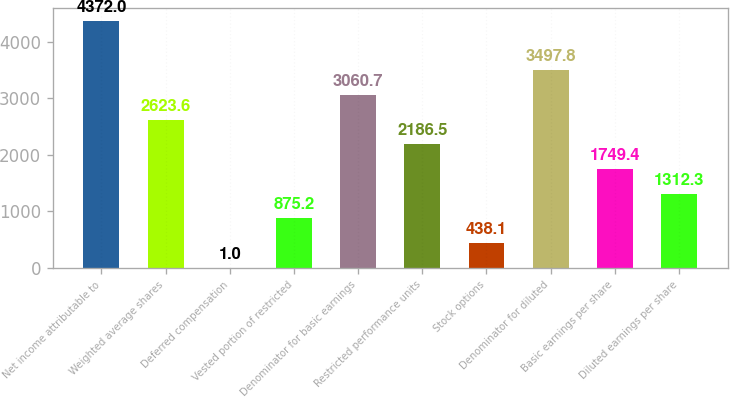Convert chart to OTSL. <chart><loc_0><loc_0><loc_500><loc_500><bar_chart><fcel>Net income attributable to<fcel>Weighted average shares<fcel>Deferred compensation<fcel>Vested portion of restricted<fcel>Denominator for basic earnings<fcel>Restricted performance units<fcel>Stock options<fcel>Denominator for diluted<fcel>Basic earnings per share<fcel>Diluted earnings per share<nl><fcel>4372<fcel>2623.6<fcel>1<fcel>875.2<fcel>3060.7<fcel>2186.5<fcel>438.1<fcel>3497.8<fcel>1749.4<fcel>1312.3<nl></chart> 